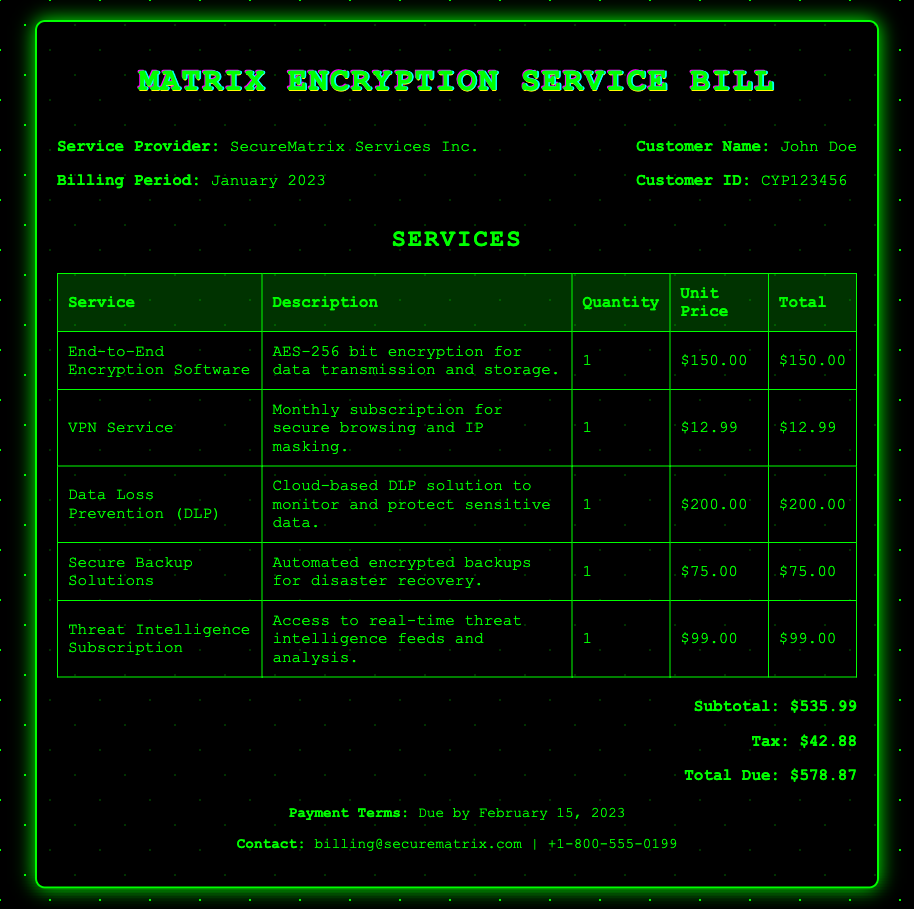What is the customer name? This information is found in the header section of the document where the customer's identification details are provided.
Answer: John Doe What is the billing period? The billing period is mentioned alongside the service provider's details in the header section.
Answer: January 2023 What is the total due amount? This is the final amount listed in the total section of the document, summing up subtotal and tax.
Answer: $578.87 How much does the VPN service cost? The cost for the VPN service is included in the service table under its respective pricing column.
Answer: $12.99 What type of encryption does the End-to-End Encryption Software provide? This information is found in the description of the End-to-End Encryption Software in the services table.
Answer: AES-256 bit What is the subtotal for the services provided? The subtotal is specifically listed in the total section and represents the total of all services before tax.
Answer: $535.99 When is the payment due? The payment terms are found in the footer section, specifying when the payment should be completed.
Answer: February 15, 2023 What is included in the description of Data Loss Prevention? The description summarizing what Data Loss Prevention does is in the services table under that service's entry.
Answer: Cloud-based DLP solution to monitor and protect sensitive data How many services are listed in the document? The services table showcases the number of listed services which can be counted directly.
Answer: 5 